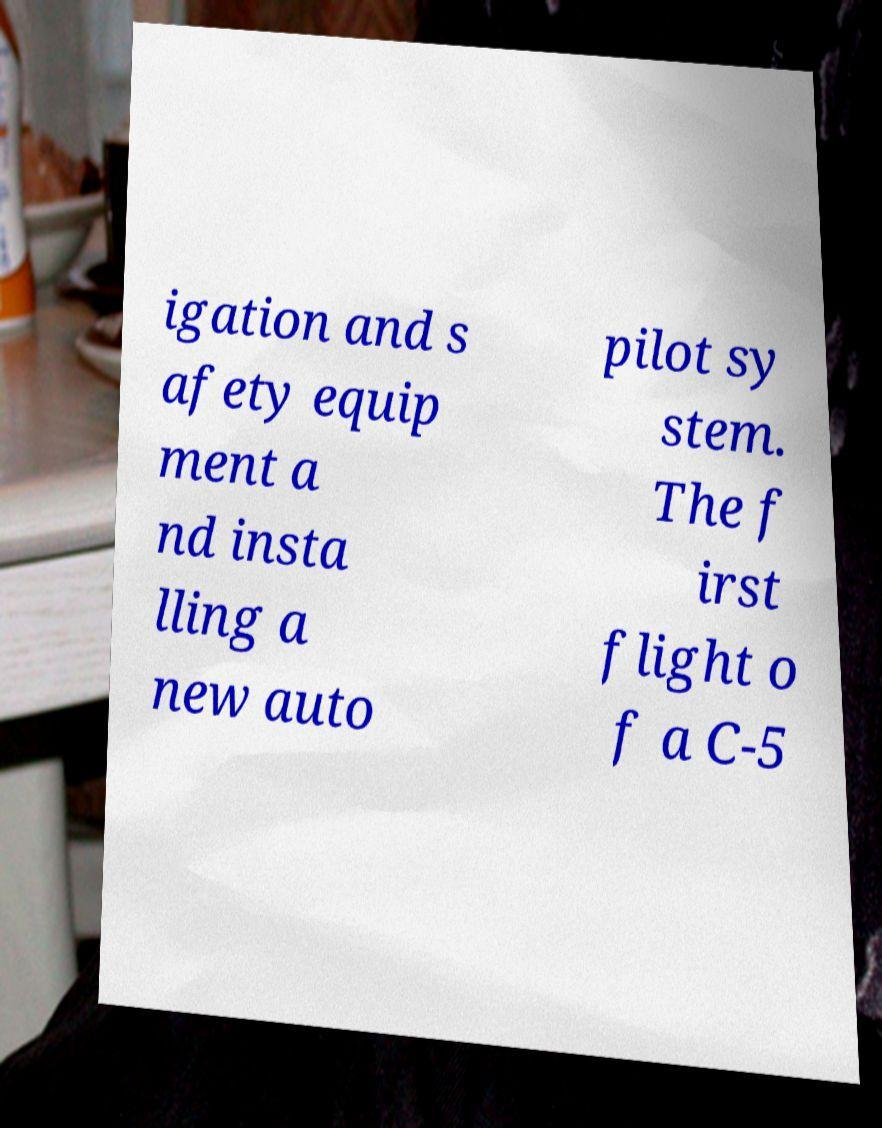Please read and relay the text visible in this image. What does it say? igation and s afety equip ment a nd insta lling a new auto pilot sy stem. The f irst flight o f a C-5 